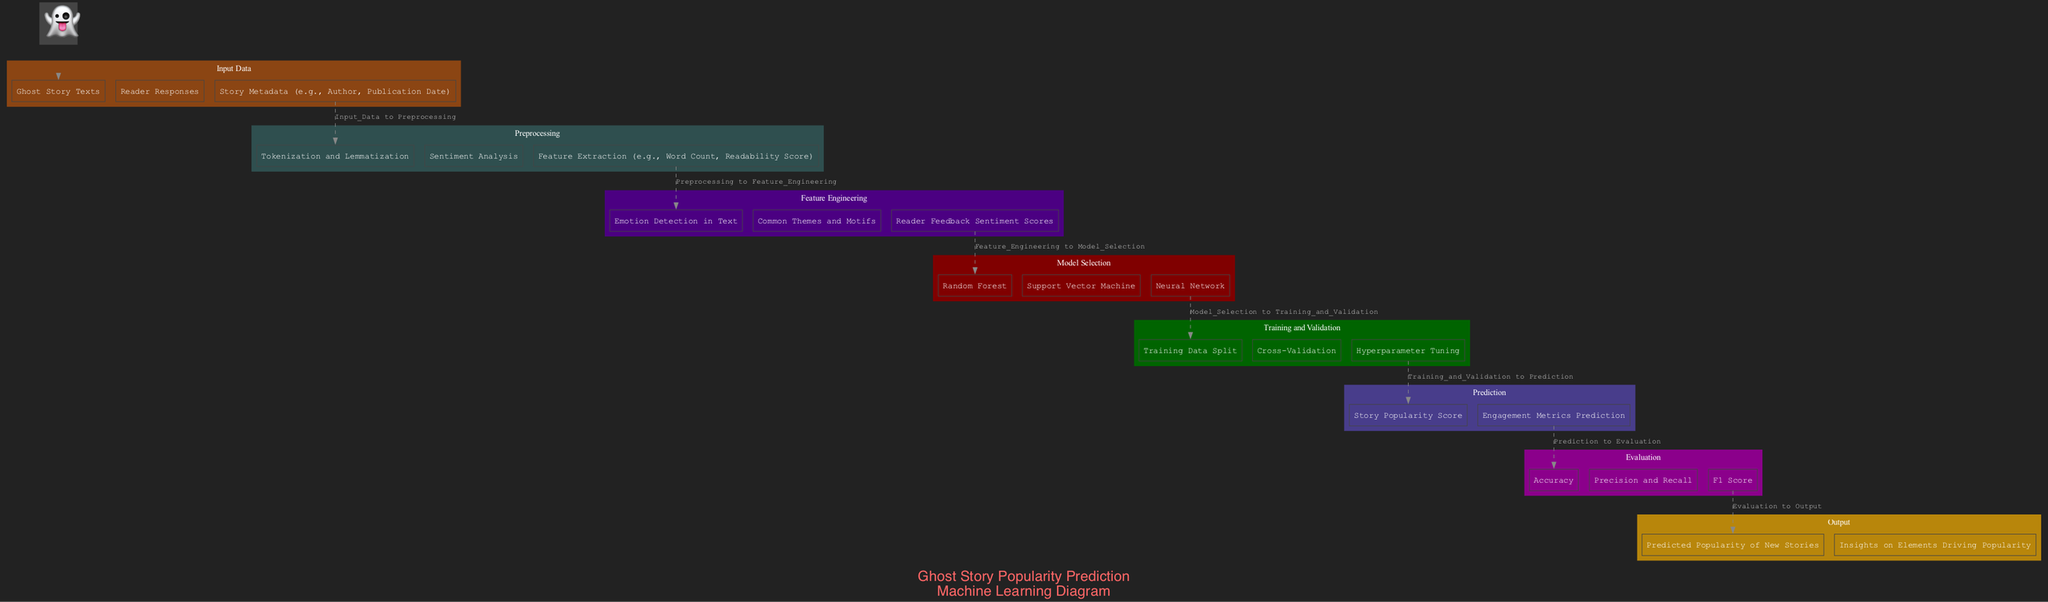What are the inputs for the model? The inputs for the model are listed in the "Input_Data" stage of the diagram, which includes "Ghost Story Texts", "Reader Responses", and "Story Metadata".
Answer: Ghost Story Texts, Reader Responses, Story Metadata How many elements are in the Preprocessing stage? The Preprocessing stage contains three elements: "Tokenization and Lemmatization", "Sentiment Analysis", and "Feature Extraction". By counting these elements, we determine there are three.
Answer: 3 What is the final output of the diagram? The final output element found in the "Output" stage states that it predicts the "Predicted Popularity of New Stories" and provides "Insights on Elements Driving Popularity". Hence the final output encompasses both of these aspects.
Answer: Predicted Popularity of New Stories, Insights on Elements Driving Popularity Which model is part of Model Selection? The "Model Selection" stage includes three models. One of them is "Random Forest," as it is explicitly listed in that section. We identify this model through direct examination of the "Model_Selection" node.
Answer: Random Forest How does Feature Engineering relate to Preprocessing? To understand the relationship, we follow the flow from "Preprocessing" to "Feature Engineering". Preprocessing is an earlier stage that prepares data by performing tasks such as tokenization, and then the processed data is utilized in the Feature Engineering stage. Therefore, Feature Engineering directly builds upon the results of Preprocessing.
Answer: Feature Engineering builds upon Preprocessing What evaluation metrics are mentioned in the Evaluation stage? The "Evaluation" stage includes three specific metrics: "Accuracy", "Precision and Recall", and "F1 Score". We identify these metrics by inspecting the items listed in the Evaluation section of the diagram.
Answer: Accuracy, Precision and Recall, F1 Score What comes after Model Selection in the diagram? Following the "Model Selection" stage, the next stage in the flow is "Training and Validation". This is determined by examining the sequential layout of the elements in the diagram.
Answer: Training and Validation Which preprocessing technique focuses on understanding the sentiment of the text? The technique listed in the "Preprocessing" stage that is specifically aimed at understanding sentiment is "Sentiment Analysis". We pinpoint this by reviewing the tasks included in the Preprocessing section.
Answer: Sentiment Analysis 